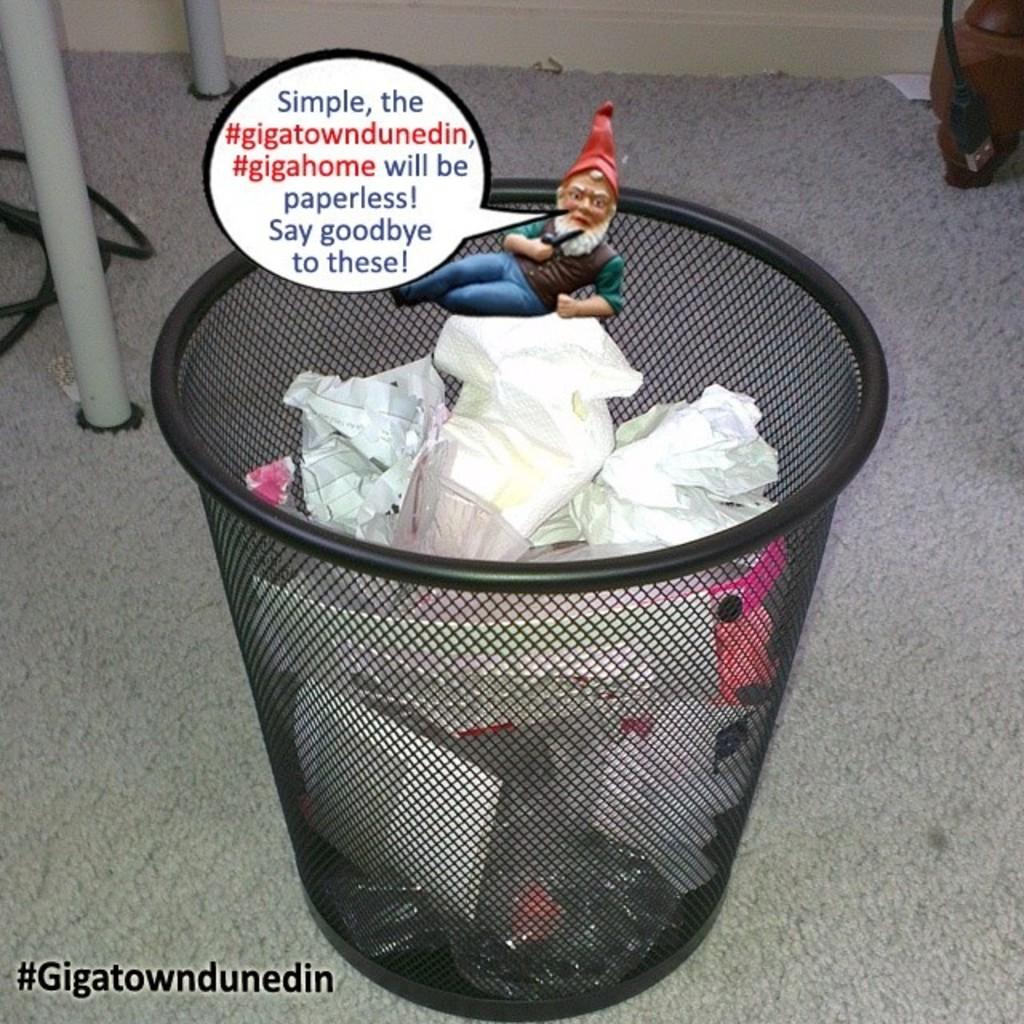What does the second hashtag say?
Offer a terse response. #gigahome. What does the last sentence in the bubble say?
Give a very brief answer. Say goodbye to these!. 